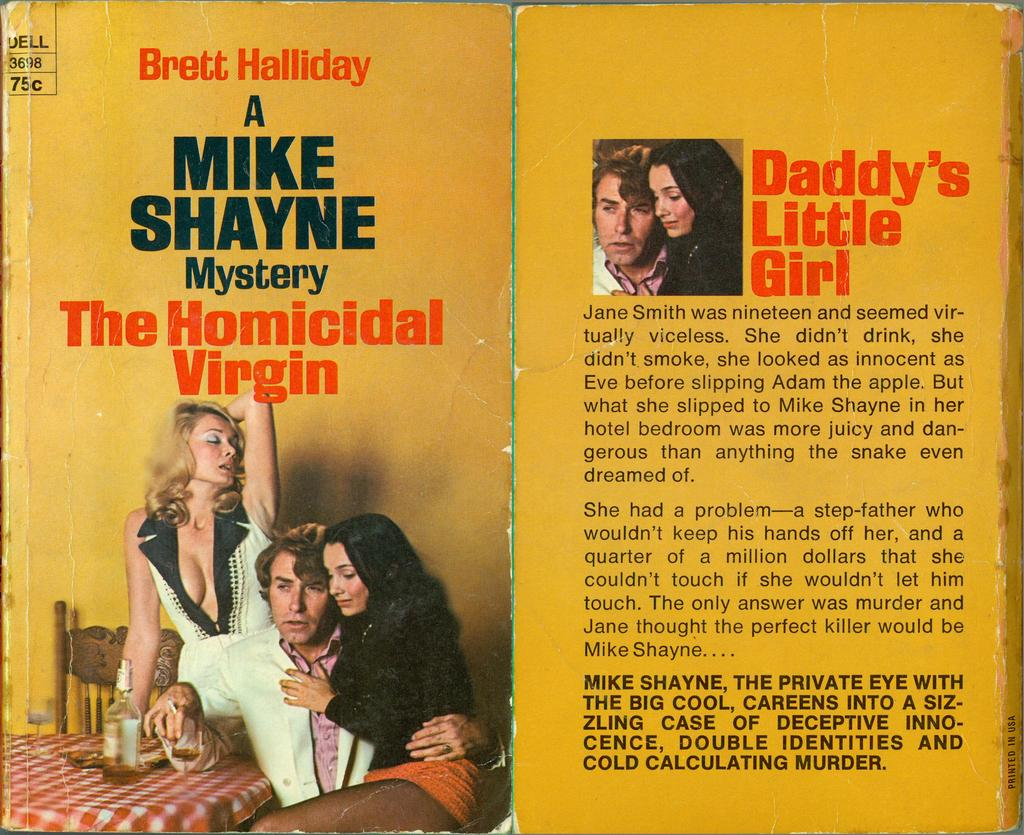What is the main subject of the image? The main subject of the image is a magazine. What colors are used for the writing on the magazine? The writing on the magazine is in black, red, and white colors. How many images are present on the magazine? There are two images on the magazine. Who is the creator of the jam featured in one of the images on the magazine? There is no jam featured in any of the images on the magazine, so it is not possible to determine the creator. 